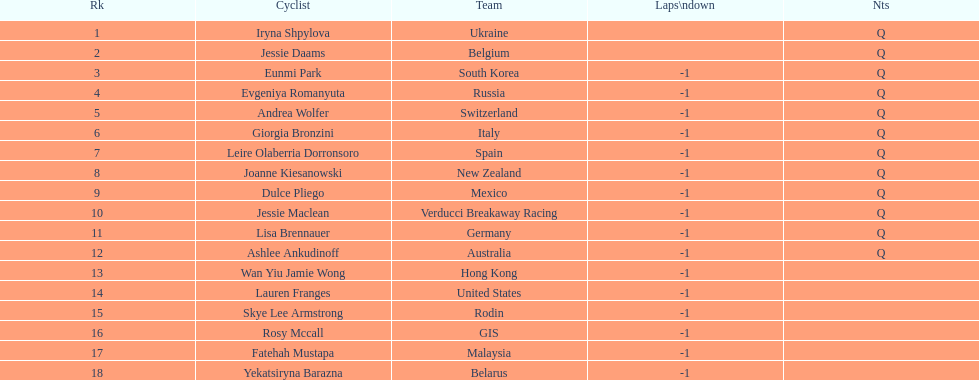Who was the top ranked competitor in this race? Iryna Shpylova. 